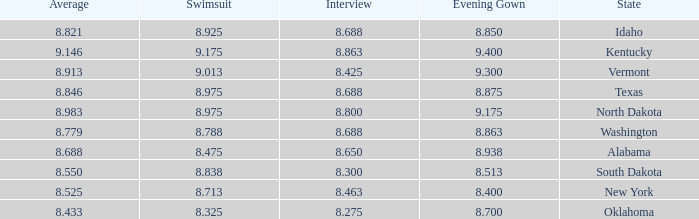Who had the lowest interview score from South Dakota with an evening gown less than 8.513? None. 